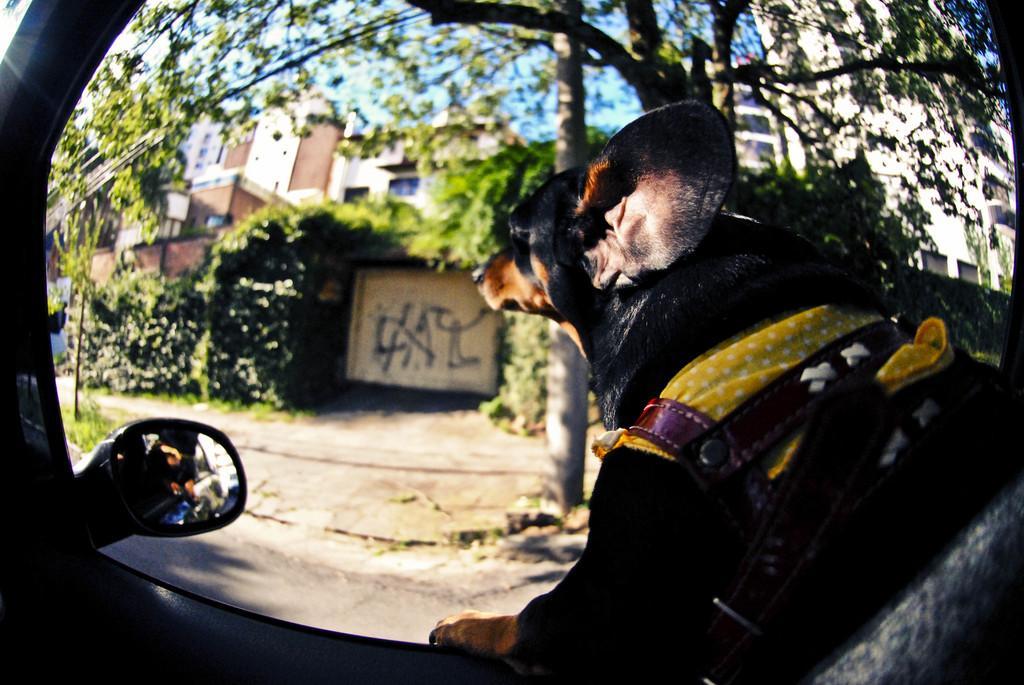Describe this image in one or two sentences. This picture is taken in a car, In the right side there is a dog which is in black color, In the left side there is a mirror of the car, In the background there are some green color plants and trees and there is a white color door in the middle. 